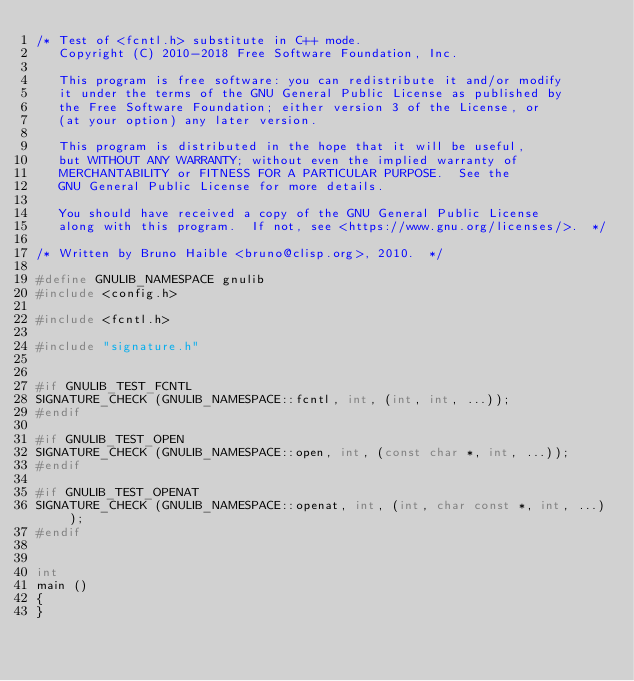<code> <loc_0><loc_0><loc_500><loc_500><_C++_>/* Test of <fcntl.h> substitute in C++ mode.
   Copyright (C) 2010-2018 Free Software Foundation, Inc.

   This program is free software: you can redistribute it and/or modify
   it under the terms of the GNU General Public License as published by
   the Free Software Foundation; either version 3 of the License, or
   (at your option) any later version.

   This program is distributed in the hope that it will be useful,
   but WITHOUT ANY WARRANTY; without even the implied warranty of
   MERCHANTABILITY or FITNESS FOR A PARTICULAR PURPOSE.  See the
   GNU General Public License for more details.

   You should have received a copy of the GNU General Public License
   along with this program.  If not, see <https://www.gnu.org/licenses/>.  */

/* Written by Bruno Haible <bruno@clisp.org>, 2010.  */

#define GNULIB_NAMESPACE gnulib
#include <config.h>

#include <fcntl.h>

#include "signature.h"


#if GNULIB_TEST_FCNTL
SIGNATURE_CHECK (GNULIB_NAMESPACE::fcntl, int, (int, int, ...));
#endif

#if GNULIB_TEST_OPEN
SIGNATURE_CHECK (GNULIB_NAMESPACE::open, int, (const char *, int, ...));
#endif

#if GNULIB_TEST_OPENAT
SIGNATURE_CHECK (GNULIB_NAMESPACE::openat, int, (int, char const *, int, ...));
#endif


int
main ()
{
}
</code> 